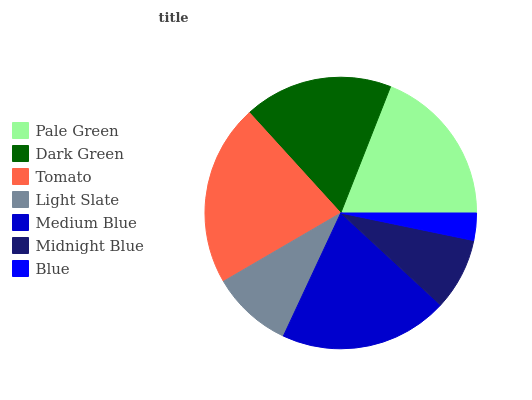Is Blue the minimum?
Answer yes or no. Yes. Is Tomato the maximum?
Answer yes or no. Yes. Is Dark Green the minimum?
Answer yes or no. No. Is Dark Green the maximum?
Answer yes or no. No. Is Pale Green greater than Dark Green?
Answer yes or no. Yes. Is Dark Green less than Pale Green?
Answer yes or no. Yes. Is Dark Green greater than Pale Green?
Answer yes or no. No. Is Pale Green less than Dark Green?
Answer yes or no. No. Is Dark Green the high median?
Answer yes or no. Yes. Is Dark Green the low median?
Answer yes or no. Yes. Is Pale Green the high median?
Answer yes or no. No. Is Tomato the low median?
Answer yes or no. No. 